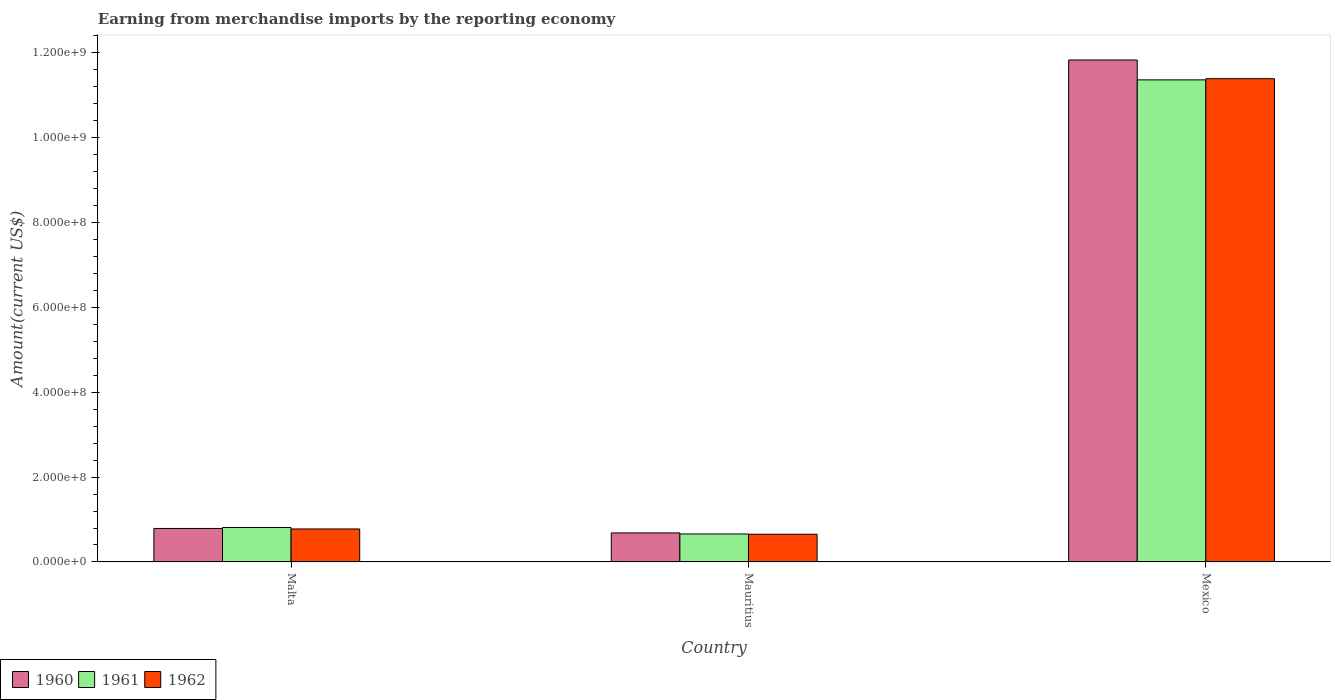How many bars are there on the 2nd tick from the right?
Make the answer very short. 3. What is the label of the 1st group of bars from the left?
Your answer should be very brief. Malta. What is the amount earned from merchandise imports in 1961 in Malta?
Give a very brief answer. 8.12e+07. Across all countries, what is the maximum amount earned from merchandise imports in 1962?
Your response must be concise. 1.14e+09. Across all countries, what is the minimum amount earned from merchandise imports in 1962?
Offer a very short reply. 6.53e+07. In which country was the amount earned from merchandise imports in 1961 maximum?
Keep it short and to the point. Mexico. In which country was the amount earned from merchandise imports in 1961 minimum?
Provide a short and direct response. Mauritius. What is the total amount earned from merchandise imports in 1962 in the graph?
Provide a short and direct response. 1.28e+09. What is the difference between the amount earned from merchandise imports in 1961 in Malta and that in Mauritius?
Provide a short and direct response. 1.53e+07. What is the difference between the amount earned from merchandise imports in 1961 in Mauritius and the amount earned from merchandise imports in 1962 in Mexico?
Keep it short and to the point. -1.07e+09. What is the average amount earned from merchandise imports in 1960 per country?
Make the answer very short. 4.43e+08. What is the difference between the amount earned from merchandise imports of/in 1962 and amount earned from merchandise imports of/in 1960 in Mexico?
Give a very brief answer. -4.41e+07. In how many countries, is the amount earned from merchandise imports in 1962 greater than 680000000 US$?
Make the answer very short. 1. What is the ratio of the amount earned from merchandise imports in 1962 in Malta to that in Mauritius?
Offer a terse response. 1.19. What is the difference between the highest and the second highest amount earned from merchandise imports in 1962?
Your answer should be compact. 1.07e+09. What is the difference between the highest and the lowest amount earned from merchandise imports in 1960?
Your answer should be very brief. 1.11e+09. In how many countries, is the amount earned from merchandise imports in 1961 greater than the average amount earned from merchandise imports in 1961 taken over all countries?
Keep it short and to the point. 1. Is the sum of the amount earned from merchandise imports in 1961 in Mauritius and Mexico greater than the maximum amount earned from merchandise imports in 1962 across all countries?
Your answer should be very brief. Yes. How many countries are there in the graph?
Provide a short and direct response. 3. Does the graph contain grids?
Ensure brevity in your answer.  No. How are the legend labels stacked?
Make the answer very short. Horizontal. What is the title of the graph?
Make the answer very short. Earning from merchandise imports by the reporting economy. Does "2015" appear as one of the legend labels in the graph?
Offer a very short reply. No. What is the label or title of the Y-axis?
Offer a terse response. Amount(current US$). What is the Amount(current US$) in 1960 in Malta?
Give a very brief answer. 7.89e+07. What is the Amount(current US$) of 1961 in Malta?
Ensure brevity in your answer.  8.12e+07. What is the Amount(current US$) in 1962 in Malta?
Your response must be concise. 7.77e+07. What is the Amount(current US$) in 1960 in Mauritius?
Keep it short and to the point. 6.84e+07. What is the Amount(current US$) in 1961 in Mauritius?
Ensure brevity in your answer.  6.59e+07. What is the Amount(current US$) in 1962 in Mauritius?
Your answer should be compact. 6.53e+07. What is the Amount(current US$) in 1960 in Mexico?
Give a very brief answer. 1.18e+09. What is the Amount(current US$) in 1961 in Mexico?
Your answer should be very brief. 1.14e+09. What is the Amount(current US$) in 1962 in Mexico?
Ensure brevity in your answer.  1.14e+09. Across all countries, what is the maximum Amount(current US$) in 1960?
Give a very brief answer. 1.18e+09. Across all countries, what is the maximum Amount(current US$) in 1961?
Ensure brevity in your answer.  1.14e+09. Across all countries, what is the maximum Amount(current US$) in 1962?
Your response must be concise. 1.14e+09. Across all countries, what is the minimum Amount(current US$) in 1960?
Your answer should be compact. 6.84e+07. Across all countries, what is the minimum Amount(current US$) of 1961?
Provide a succinct answer. 6.59e+07. Across all countries, what is the minimum Amount(current US$) in 1962?
Offer a very short reply. 6.53e+07. What is the total Amount(current US$) in 1960 in the graph?
Offer a very short reply. 1.33e+09. What is the total Amount(current US$) in 1961 in the graph?
Your response must be concise. 1.28e+09. What is the total Amount(current US$) of 1962 in the graph?
Offer a very short reply. 1.28e+09. What is the difference between the Amount(current US$) in 1960 in Malta and that in Mauritius?
Offer a very short reply. 1.05e+07. What is the difference between the Amount(current US$) of 1961 in Malta and that in Mauritius?
Give a very brief answer. 1.53e+07. What is the difference between the Amount(current US$) in 1962 in Malta and that in Mauritius?
Provide a succinct answer. 1.24e+07. What is the difference between the Amount(current US$) of 1960 in Malta and that in Mexico?
Your answer should be compact. -1.10e+09. What is the difference between the Amount(current US$) of 1961 in Malta and that in Mexico?
Provide a short and direct response. -1.05e+09. What is the difference between the Amount(current US$) in 1962 in Malta and that in Mexico?
Your answer should be very brief. -1.06e+09. What is the difference between the Amount(current US$) in 1960 in Mauritius and that in Mexico?
Offer a very short reply. -1.11e+09. What is the difference between the Amount(current US$) in 1961 in Mauritius and that in Mexico?
Offer a terse response. -1.07e+09. What is the difference between the Amount(current US$) in 1962 in Mauritius and that in Mexico?
Give a very brief answer. -1.07e+09. What is the difference between the Amount(current US$) in 1960 in Malta and the Amount(current US$) in 1961 in Mauritius?
Keep it short and to the point. 1.30e+07. What is the difference between the Amount(current US$) in 1960 in Malta and the Amount(current US$) in 1962 in Mauritius?
Make the answer very short. 1.36e+07. What is the difference between the Amount(current US$) of 1961 in Malta and the Amount(current US$) of 1962 in Mauritius?
Provide a short and direct response. 1.59e+07. What is the difference between the Amount(current US$) of 1960 in Malta and the Amount(current US$) of 1961 in Mexico?
Ensure brevity in your answer.  -1.06e+09. What is the difference between the Amount(current US$) of 1960 in Malta and the Amount(current US$) of 1962 in Mexico?
Your answer should be compact. -1.06e+09. What is the difference between the Amount(current US$) of 1961 in Malta and the Amount(current US$) of 1962 in Mexico?
Make the answer very short. -1.06e+09. What is the difference between the Amount(current US$) in 1960 in Mauritius and the Amount(current US$) in 1961 in Mexico?
Make the answer very short. -1.07e+09. What is the difference between the Amount(current US$) in 1960 in Mauritius and the Amount(current US$) in 1962 in Mexico?
Provide a succinct answer. -1.07e+09. What is the difference between the Amount(current US$) in 1961 in Mauritius and the Amount(current US$) in 1962 in Mexico?
Offer a very short reply. -1.07e+09. What is the average Amount(current US$) in 1960 per country?
Offer a terse response. 4.43e+08. What is the average Amount(current US$) in 1961 per country?
Provide a short and direct response. 4.28e+08. What is the average Amount(current US$) in 1962 per country?
Offer a terse response. 4.27e+08. What is the difference between the Amount(current US$) in 1960 and Amount(current US$) in 1961 in Malta?
Provide a short and direct response. -2.30e+06. What is the difference between the Amount(current US$) in 1960 and Amount(current US$) in 1962 in Malta?
Offer a terse response. 1.18e+06. What is the difference between the Amount(current US$) of 1961 and Amount(current US$) of 1962 in Malta?
Your response must be concise. 3.48e+06. What is the difference between the Amount(current US$) in 1960 and Amount(current US$) in 1961 in Mauritius?
Keep it short and to the point. 2.50e+06. What is the difference between the Amount(current US$) in 1960 and Amount(current US$) in 1962 in Mauritius?
Offer a terse response. 3.10e+06. What is the difference between the Amount(current US$) in 1960 and Amount(current US$) in 1961 in Mexico?
Ensure brevity in your answer.  4.69e+07. What is the difference between the Amount(current US$) in 1960 and Amount(current US$) in 1962 in Mexico?
Keep it short and to the point. 4.41e+07. What is the difference between the Amount(current US$) of 1961 and Amount(current US$) of 1962 in Mexico?
Your answer should be very brief. -2.80e+06. What is the ratio of the Amount(current US$) of 1960 in Malta to that in Mauritius?
Your response must be concise. 1.15. What is the ratio of the Amount(current US$) of 1961 in Malta to that in Mauritius?
Ensure brevity in your answer.  1.23. What is the ratio of the Amount(current US$) of 1962 in Malta to that in Mauritius?
Your response must be concise. 1.19. What is the ratio of the Amount(current US$) in 1960 in Malta to that in Mexico?
Your answer should be very brief. 0.07. What is the ratio of the Amount(current US$) in 1961 in Malta to that in Mexico?
Provide a short and direct response. 0.07. What is the ratio of the Amount(current US$) of 1962 in Malta to that in Mexico?
Your response must be concise. 0.07. What is the ratio of the Amount(current US$) of 1960 in Mauritius to that in Mexico?
Your response must be concise. 0.06. What is the ratio of the Amount(current US$) of 1961 in Mauritius to that in Mexico?
Give a very brief answer. 0.06. What is the ratio of the Amount(current US$) in 1962 in Mauritius to that in Mexico?
Provide a succinct answer. 0.06. What is the difference between the highest and the second highest Amount(current US$) in 1960?
Provide a short and direct response. 1.10e+09. What is the difference between the highest and the second highest Amount(current US$) in 1961?
Provide a succinct answer. 1.05e+09. What is the difference between the highest and the second highest Amount(current US$) in 1962?
Keep it short and to the point. 1.06e+09. What is the difference between the highest and the lowest Amount(current US$) in 1960?
Your response must be concise. 1.11e+09. What is the difference between the highest and the lowest Amount(current US$) in 1961?
Your answer should be very brief. 1.07e+09. What is the difference between the highest and the lowest Amount(current US$) of 1962?
Your answer should be very brief. 1.07e+09. 